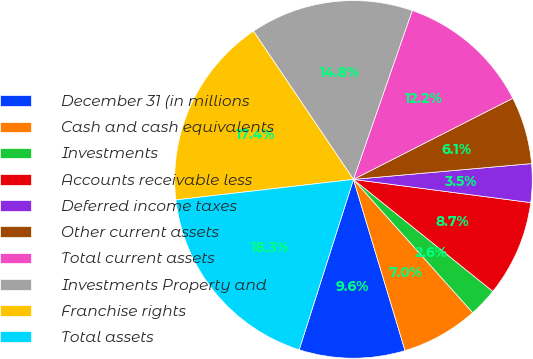<chart> <loc_0><loc_0><loc_500><loc_500><pie_chart><fcel>December 31 (in millions<fcel>Cash and cash equivalents<fcel>Investments<fcel>Accounts receivable less<fcel>Deferred income taxes<fcel>Other current assets<fcel>Total current assets<fcel>Investments Property and<fcel>Franchise rights<fcel>Total assets<nl><fcel>9.57%<fcel>6.96%<fcel>2.61%<fcel>8.7%<fcel>3.48%<fcel>6.09%<fcel>12.17%<fcel>14.78%<fcel>17.39%<fcel>18.26%<nl></chart> 